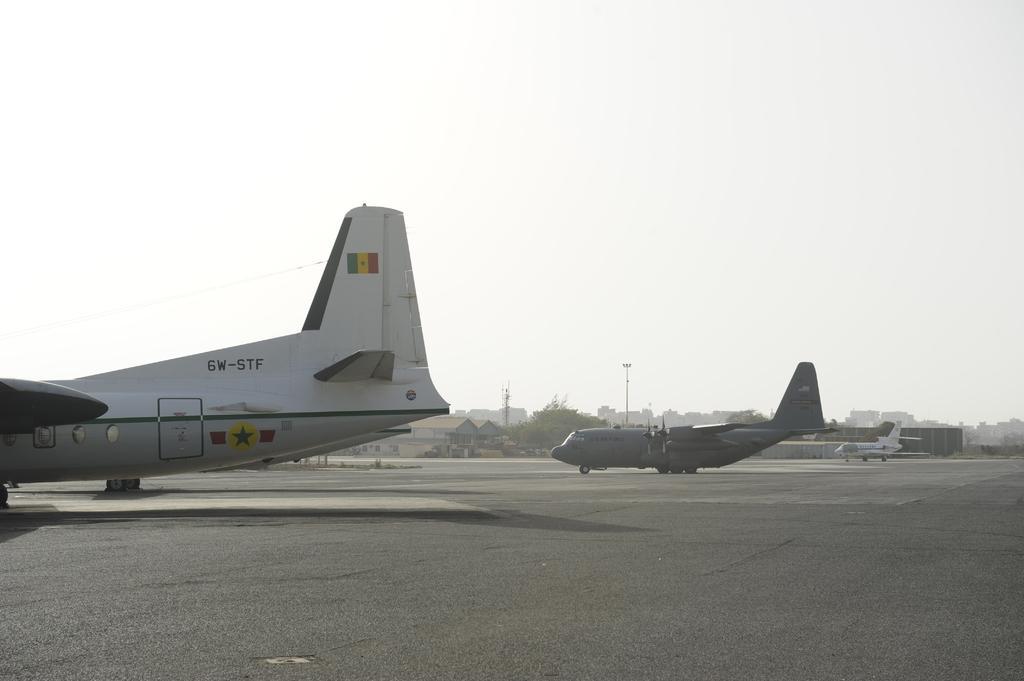Could you give a brief overview of what you see in this image? In this image I can see a aircraft which is white and black in color on the runway. In the background I can see few other aircraft's, few buildings, few trees, few poles and the sky. 